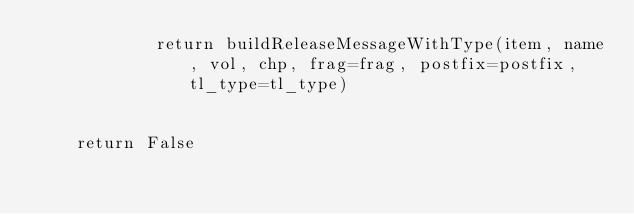Convert code to text. <code><loc_0><loc_0><loc_500><loc_500><_Python_>			return buildReleaseMessageWithType(item, name, vol, chp, frag=frag, postfix=postfix, tl_type=tl_type)


	return False
	</code> 